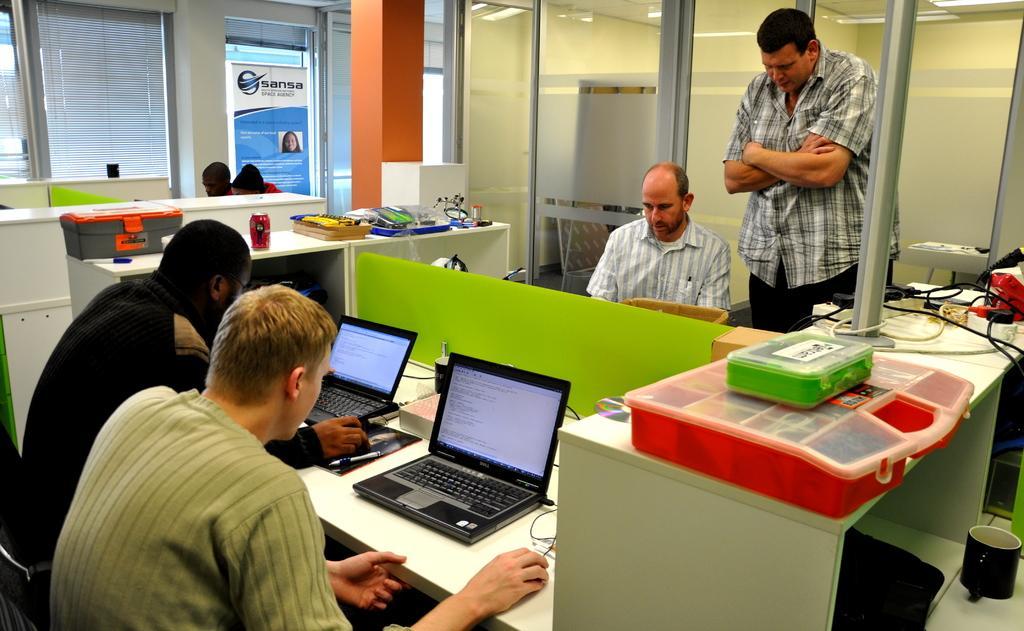Please provide a concise description of this image. Here in the left side we can see two people sitting on chairs and handling laptops and right in front of them there is a man sitting and man standing and here we can see some boxes, this whole thing is like in office 